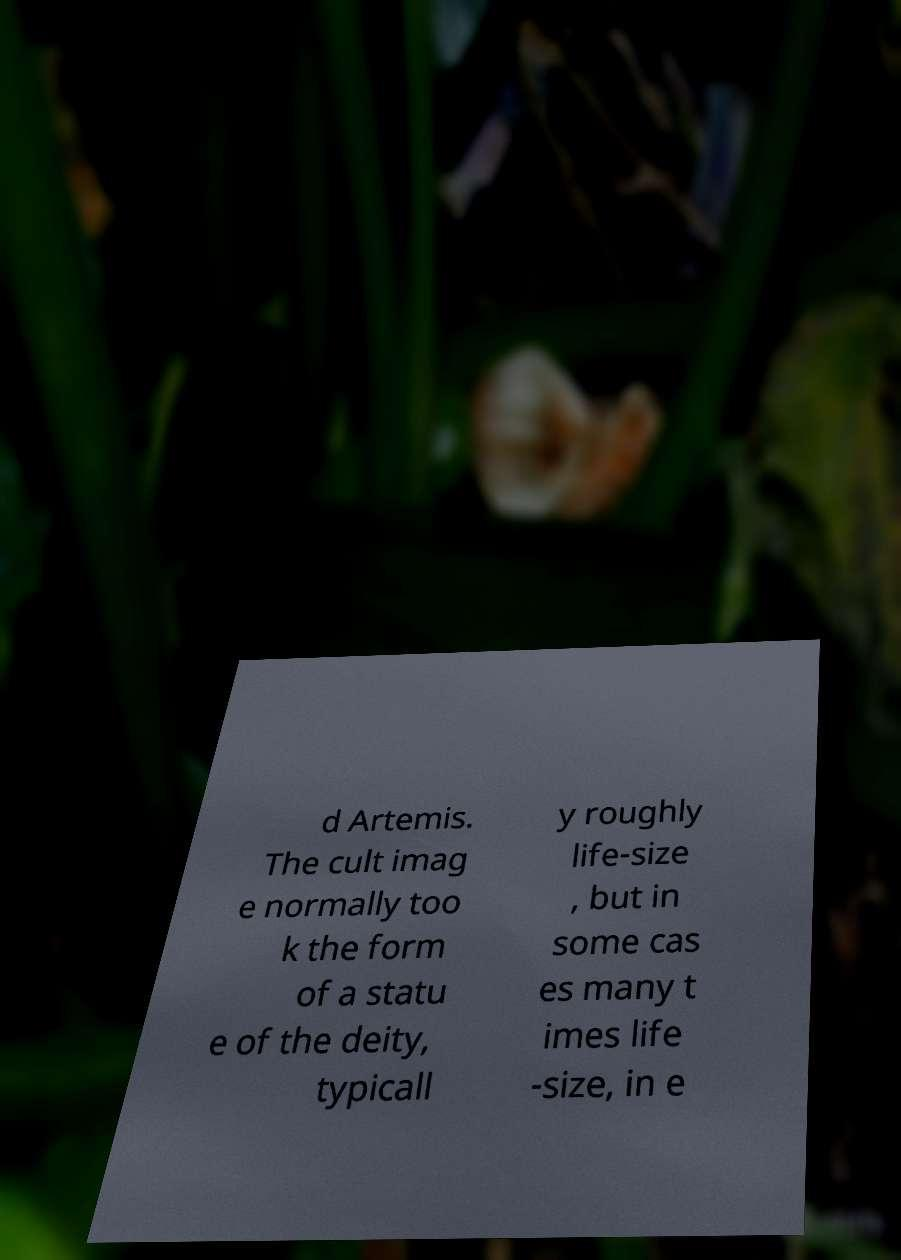Please read and relay the text visible in this image. What does it say? d Artemis. The cult imag e normally too k the form of a statu e of the deity, typicall y roughly life-size , but in some cas es many t imes life -size, in e 